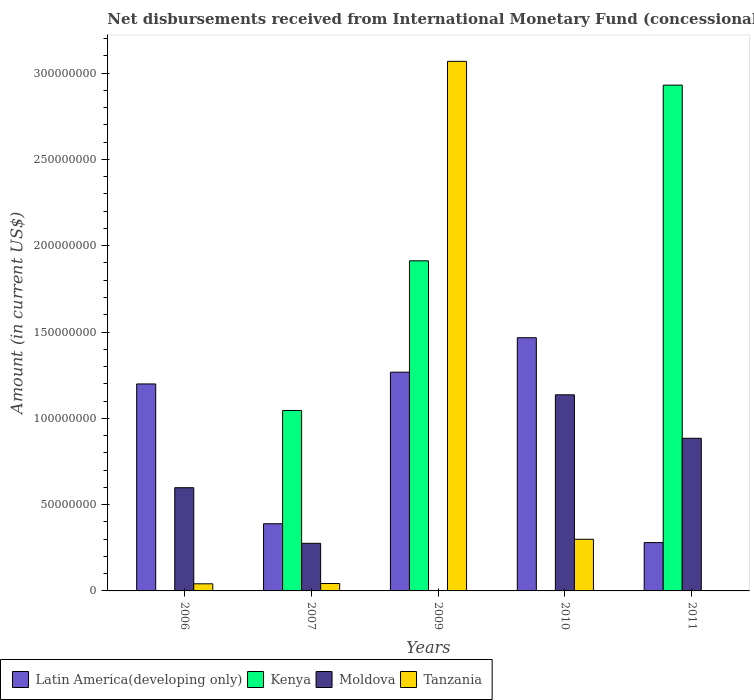How many different coloured bars are there?
Offer a terse response. 4. How many groups of bars are there?
Provide a short and direct response. 5. Are the number of bars per tick equal to the number of legend labels?
Your answer should be very brief. No. How many bars are there on the 2nd tick from the right?
Offer a very short reply. 3. What is the label of the 4th group of bars from the left?
Give a very brief answer. 2010. What is the amount of disbursements received from International Monetary Fund in Latin America(developing only) in 2010?
Ensure brevity in your answer.  1.47e+08. Across all years, what is the maximum amount of disbursements received from International Monetary Fund in Moldova?
Your answer should be very brief. 1.14e+08. In which year was the amount of disbursements received from International Monetary Fund in Moldova maximum?
Make the answer very short. 2010. What is the total amount of disbursements received from International Monetary Fund in Tanzania in the graph?
Provide a succinct answer. 3.45e+08. What is the difference between the amount of disbursements received from International Monetary Fund in Latin America(developing only) in 2006 and that in 2010?
Your answer should be compact. -2.68e+07. What is the difference between the amount of disbursements received from International Monetary Fund in Moldova in 2007 and the amount of disbursements received from International Monetary Fund in Tanzania in 2011?
Your answer should be compact. 2.76e+07. What is the average amount of disbursements received from International Monetary Fund in Latin America(developing only) per year?
Your answer should be very brief. 9.20e+07. In the year 2007, what is the difference between the amount of disbursements received from International Monetary Fund in Tanzania and amount of disbursements received from International Monetary Fund in Moldova?
Offer a very short reply. -2.33e+07. What is the ratio of the amount of disbursements received from International Monetary Fund in Latin America(developing only) in 2006 to that in 2010?
Offer a very short reply. 0.82. Is the amount of disbursements received from International Monetary Fund in Latin America(developing only) in 2006 less than that in 2010?
Your response must be concise. Yes. What is the difference between the highest and the second highest amount of disbursements received from International Monetary Fund in Tanzania?
Your answer should be compact. 2.77e+08. What is the difference between the highest and the lowest amount of disbursements received from International Monetary Fund in Kenya?
Make the answer very short. 2.93e+08. In how many years, is the amount of disbursements received from International Monetary Fund in Kenya greater than the average amount of disbursements received from International Monetary Fund in Kenya taken over all years?
Offer a terse response. 2. Is it the case that in every year, the sum of the amount of disbursements received from International Monetary Fund in Tanzania and amount of disbursements received from International Monetary Fund in Kenya is greater than the amount of disbursements received from International Monetary Fund in Latin America(developing only)?
Your response must be concise. No. How many bars are there?
Offer a terse response. 16. Are all the bars in the graph horizontal?
Provide a succinct answer. No. What is the difference between two consecutive major ticks on the Y-axis?
Your response must be concise. 5.00e+07. Are the values on the major ticks of Y-axis written in scientific E-notation?
Your answer should be compact. No. Does the graph contain any zero values?
Ensure brevity in your answer.  Yes. Does the graph contain grids?
Your answer should be very brief. No. How many legend labels are there?
Offer a terse response. 4. What is the title of the graph?
Ensure brevity in your answer.  Net disbursements received from International Monetary Fund (concessional). Does "Uganda" appear as one of the legend labels in the graph?
Your answer should be very brief. No. What is the label or title of the X-axis?
Keep it short and to the point. Years. What is the label or title of the Y-axis?
Your response must be concise. Amount (in current US$). What is the Amount (in current US$) in Latin America(developing only) in 2006?
Your answer should be very brief. 1.20e+08. What is the Amount (in current US$) of Kenya in 2006?
Ensure brevity in your answer.  0. What is the Amount (in current US$) in Moldova in 2006?
Keep it short and to the point. 5.98e+07. What is the Amount (in current US$) of Tanzania in 2006?
Give a very brief answer. 4.12e+06. What is the Amount (in current US$) of Latin America(developing only) in 2007?
Your response must be concise. 3.89e+07. What is the Amount (in current US$) in Kenya in 2007?
Provide a short and direct response. 1.05e+08. What is the Amount (in current US$) of Moldova in 2007?
Give a very brief answer. 2.76e+07. What is the Amount (in current US$) of Tanzania in 2007?
Your answer should be very brief. 4.29e+06. What is the Amount (in current US$) in Latin America(developing only) in 2009?
Keep it short and to the point. 1.27e+08. What is the Amount (in current US$) in Kenya in 2009?
Ensure brevity in your answer.  1.91e+08. What is the Amount (in current US$) in Tanzania in 2009?
Your answer should be very brief. 3.07e+08. What is the Amount (in current US$) in Latin America(developing only) in 2010?
Provide a succinct answer. 1.47e+08. What is the Amount (in current US$) in Moldova in 2010?
Provide a succinct answer. 1.14e+08. What is the Amount (in current US$) of Tanzania in 2010?
Ensure brevity in your answer.  2.99e+07. What is the Amount (in current US$) of Latin America(developing only) in 2011?
Give a very brief answer. 2.80e+07. What is the Amount (in current US$) in Kenya in 2011?
Provide a short and direct response. 2.93e+08. What is the Amount (in current US$) in Moldova in 2011?
Provide a short and direct response. 8.84e+07. What is the Amount (in current US$) of Tanzania in 2011?
Ensure brevity in your answer.  0. Across all years, what is the maximum Amount (in current US$) in Latin America(developing only)?
Your answer should be compact. 1.47e+08. Across all years, what is the maximum Amount (in current US$) in Kenya?
Provide a succinct answer. 2.93e+08. Across all years, what is the maximum Amount (in current US$) of Moldova?
Provide a short and direct response. 1.14e+08. Across all years, what is the maximum Amount (in current US$) of Tanzania?
Offer a very short reply. 3.07e+08. Across all years, what is the minimum Amount (in current US$) of Latin America(developing only)?
Your answer should be compact. 2.80e+07. Across all years, what is the minimum Amount (in current US$) in Kenya?
Your answer should be very brief. 0. Across all years, what is the minimum Amount (in current US$) in Tanzania?
Your response must be concise. 0. What is the total Amount (in current US$) of Latin America(developing only) in the graph?
Your response must be concise. 4.60e+08. What is the total Amount (in current US$) in Kenya in the graph?
Offer a very short reply. 5.89e+08. What is the total Amount (in current US$) in Moldova in the graph?
Your answer should be very brief. 2.89e+08. What is the total Amount (in current US$) in Tanzania in the graph?
Keep it short and to the point. 3.45e+08. What is the difference between the Amount (in current US$) in Latin America(developing only) in 2006 and that in 2007?
Your answer should be compact. 8.10e+07. What is the difference between the Amount (in current US$) in Moldova in 2006 and that in 2007?
Your response must be concise. 3.22e+07. What is the difference between the Amount (in current US$) in Tanzania in 2006 and that in 2007?
Your answer should be very brief. -1.66e+05. What is the difference between the Amount (in current US$) of Latin America(developing only) in 2006 and that in 2009?
Your response must be concise. -6.82e+06. What is the difference between the Amount (in current US$) of Tanzania in 2006 and that in 2009?
Ensure brevity in your answer.  -3.03e+08. What is the difference between the Amount (in current US$) of Latin America(developing only) in 2006 and that in 2010?
Your answer should be compact. -2.68e+07. What is the difference between the Amount (in current US$) in Moldova in 2006 and that in 2010?
Ensure brevity in your answer.  -5.38e+07. What is the difference between the Amount (in current US$) in Tanzania in 2006 and that in 2010?
Offer a very short reply. -2.58e+07. What is the difference between the Amount (in current US$) in Latin America(developing only) in 2006 and that in 2011?
Make the answer very short. 9.19e+07. What is the difference between the Amount (in current US$) in Moldova in 2006 and that in 2011?
Your answer should be compact. -2.86e+07. What is the difference between the Amount (in current US$) in Latin America(developing only) in 2007 and that in 2009?
Your answer should be compact. -8.78e+07. What is the difference between the Amount (in current US$) in Kenya in 2007 and that in 2009?
Your response must be concise. -8.67e+07. What is the difference between the Amount (in current US$) of Tanzania in 2007 and that in 2009?
Keep it short and to the point. -3.03e+08. What is the difference between the Amount (in current US$) in Latin America(developing only) in 2007 and that in 2010?
Your response must be concise. -1.08e+08. What is the difference between the Amount (in current US$) of Moldova in 2007 and that in 2010?
Your answer should be compact. -8.60e+07. What is the difference between the Amount (in current US$) in Tanzania in 2007 and that in 2010?
Your response must be concise. -2.56e+07. What is the difference between the Amount (in current US$) of Latin America(developing only) in 2007 and that in 2011?
Ensure brevity in your answer.  1.09e+07. What is the difference between the Amount (in current US$) of Kenya in 2007 and that in 2011?
Keep it short and to the point. -1.88e+08. What is the difference between the Amount (in current US$) in Moldova in 2007 and that in 2011?
Make the answer very short. -6.09e+07. What is the difference between the Amount (in current US$) of Latin America(developing only) in 2009 and that in 2010?
Offer a terse response. -2.00e+07. What is the difference between the Amount (in current US$) of Tanzania in 2009 and that in 2010?
Make the answer very short. 2.77e+08. What is the difference between the Amount (in current US$) in Latin America(developing only) in 2009 and that in 2011?
Give a very brief answer. 9.87e+07. What is the difference between the Amount (in current US$) of Kenya in 2009 and that in 2011?
Your answer should be very brief. -1.02e+08. What is the difference between the Amount (in current US$) of Latin America(developing only) in 2010 and that in 2011?
Keep it short and to the point. 1.19e+08. What is the difference between the Amount (in current US$) of Moldova in 2010 and that in 2011?
Provide a succinct answer. 2.52e+07. What is the difference between the Amount (in current US$) of Latin America(developing only) in 2006 and the Amount (in current US$) of Kenya in 2007?
Your answer should be very brief. 1.54e+07. What is the difference between the Amount (in current US$) in Latin America(developing only) in 2006 and the Amount (in current US$) in Moldova in 2007?
Ensure brevity in your answer.  9.23e+07. What is the difference between the Amount (in current US$) of Latin America(developing only) in 2006 and the Amount (in current US$) of Tanzania in 2007?
Provide a succinct answer. 1.16e+08. What is the difference between the Amount (in current US$) in Moldova in 2006 and the Amount (in current US$) in Tanzania in 2007?
Offer a very short reply. 5.55e+07. What is the difference between the Amount (in current US$) in Latin America(developing only) in 2006 and the Amount (in current US$) in Kenya in 2009?
Offer a very short reply. -7.13e+07. What is the difference between the Amount (in current US$) in Latin America(developing only) in 2006 and the Amount (in current US$) in Tanzania in 2009?
Your response must be concise. -1.87e+08. What is the difference between the Amount (in current US$) in Moldova in 2006 and the Amount (in current US$) in Tanzania in 2009?
Your answer should be very brief. -2.47e+08. What is the difference between the Amount (in current US$) of Latin America(developing only) in 2006 and the Amount (in current US$) of Moldova in 2010?
Give a very brief answer. 6.30e+06. What is the difference between the Amount (in current US$) in Latin America(developing only) in 2006 and the Amount (in current US$) in Tanzania in 2010?
Make the answer very short. 9.00e+07. What is the difference between the Amount (in current US$) of Moldova in 2006 and the Amount (in current US$) of Tanzania in 2010?
Your answer should be very brief. 2.99e+07. What is the difference between the Amount (in current US$) in Latin America(developing only) in 2006 and the Amount (in current US$) in Kenya in 2011?
Your response must be concise. -1.73e+08. What is the difference between the Amount (in current US$) of Latin America(developing only) in 2006 and the Amount (in current US$) of Moldova in 2011?
Your answer should be compact. 3.15e+07. What is the difference between the Amount (in current US$) of Latin America(developing only) in 2007 and the Amount (in current US$) of Kenya in 2009?
Give a very brief answer. -1.52e+08. What is the difference between the Amount (in current US$) of Latin America(developing only) in 2007 and the Amount (in current US$) of Tanzania in 2009?
Make the answer very short. -2.68e+08. What is the difference between the Amount (in current US$) in Kenya in 2007 and the Amount (in current US$) in Tanzania in 2009?
Offer a very short reply. -2.02e+08. What is the difference between the Amount (in current US$) in Moldova in 2007 and the Amount (in current US$) in Tanzania in 2009?
Keep it short and to the point. -2.79e+08. What is the difference between the Amount (in current US$) in Latin America(developing only) in 2007 and the Amount (in current US$) in Moldova in 2010?
Give a very brief answer. -7.47e+07. What is the difference between the Amount (in current US$) of Latin America(developing only) in 2007 and the Amount (in current US$) of Tanzania in 2010?
Make the answer very short. 8.99e+06. What is the difference between the Amount (in current US$) of Kenya in 2007 and the Amount (in current US$) of Moldova in 2010?
Offer a terse response. -9.09e+06. What is the difference between the Amount (in current US$) of Kenya in 2007 and the Amount (in current US$) of Tanzania in 2010?
Your answer should be very brief. 7.46e+07. What is the difference between the Amount (in current US$) in Moldova in 2007 and the Amount (in current US$) in Tanzania in 2010?
Your answer should be very brief. -2.35e+06. What is the difference between the Amount (in current US$) of Latin America(developing only) in 2007 and the Amount (in current US$) of Kenya in 2011?
Your response must be concise. -2.54e+08. What is the difference between the Amount (in current US$) in Latin America(developing only) in 2007 and the Amount (in current US$) in Moldova in 2011?
Your answer should be compact. -4.95e+07. What is the difference between the Amount (in current US$) of Kenya in 2007 and the Amount (in current US$) of Moldova in 2011?
Ensure brevity in your answer.  1.61e+07. What is the difference between the Amount (in current US$) of Latin America(developing only) in 2009 and the Amount (in current US$) of Moldova in 2010?
Your response must be concise. 1.31e+07. What is the difference between the Amount (in current US$) in Latin America(developing only) in 2009 and the Amount (in current US$) in Tanzania in 2010?
Provide a succinct answer. 9.68e+07. What is the difference between the Amount (in current US$) in Kenya in 2009 and the Amount (in current US$) in Moldova in 2010?
Provide a succinct answer. 7.76e+07. What is the difference between the Amount (in current US$) of Kenya in 2009 and the Amount (in current US$) of Tanzania in 2010?
Give a very brief answer. 1.61e+08. What is the difference between the Amount (in current US$) of Latin America(developing only) in 2009 and the Amount (in current US$) of Kenya in 2011?
Provide a succinct answer. -1.66e+08. What is the difference between the Amount (in current US$) in Latin America(developing only) in 2009 and the Amount (in current US$) in Moldova in 2011?
Provide a short and direct response. 3.83e+07. What is the difference between the Amount (in current US$) of Kenya in 2009 and the Amount (in current US$) of Moldova in 2011?
Ensure brevity in your answer.  1.03e+08. What is the difference between the Amount (in current US$) of Latin America(developing only) in 2010 and the Amount (in current US$) of Kenya in 2011?
Provide a succinct answer. -1.46e+08. What is the difference between the Amount (in current US$) in Latin America(developing only) in 2010 and the Amount (in current US$) in Moldova in 2011?
Your answer should be very brief. 5.83e+07. What is the average Amount (in current US$) in Latin America(developing only) per year?
Your response must be concise. 9.20e+07. What is the average Amount (in current US$) in Kenya per year?
Your answer should be compact. 1.18e+08. What is the average Amount (in current US$) in Moldova per year?
Ensure brevity in your answer.  5.79e+07. What is the average Amount (in current US$) of Tanzania per year?
Keep it short and to the point. 6.90e+07. In the year 2006, what is the difference between the Amount (in current US$) of Latin America(developing only) and Amount (in current US$) of Moldova?
Offer a terse response. 6.01e+07. In the year 2006, what is the difference between the Amount (in current US$) of Latin America(developing only) and Amount (in current US$) of Tanzania?
Give a very brief answer. 1.16e+08. In the year 2006, what is the difference between the Amount (in current US$) of Moldova and Amount (in current US$) of Tanzania?
Provide a succinct answer. 5.57e+07. In the year 2007, what is the difference between the Amount (in current US$) of Latin America(developing only) and Amount (in current US$) of Kenya?
Your answer should be compact. -6.56e+07. In the year 2007, what is the difference between the Amount (in current US$) of Latin America(developing only) and Amount (in current US$) of Moldova?
Give a very brief answer. 1.13e+07. In the year 2007, what is the difference between the Amount (in current US$) of Latin America(developing only) and Amount (in current US$) of Tanzania?
Your answer should be very brief. 3.46e+07. In the year 2007, what is the difference between the Amount (in current US$) in Kenya and Amount (in current US$) in Moldova?
Give a very brief answer. 7.70e+07. In the year 2007, what is the difference between the Amount (in current US$) of Kenya and Amount (in current US$) of Tanzania?
Provide a short and direct response. 1.00e+08. In the year 2007, what is the difference between the Amount (in current US$) of Moldova and Amount (in current US$) of Tanzania?
Your answer should be compact. 2.33e+07. In the year 2009, what is the difference between the Amount (in current US$) of Latin America(developing only) and Amount (in current US$) of Kenya?
Your answer should be compact. -6.45e+07. In the year 2009, what is the difference between the Amount (in current US$) of Latin America(developing only) and Amount (in current US$) of Tanzania?
Offer a terse response. -1.80e+08. In the year 2009, what is the difference between the Amount (in current US$) of Kenya and Amount (in current US$) of Tanzania?
Your response must be concise. -1.16e+08. In the year 2010, what is the difference between the Amount (in current US$) in Latin America(developing only) and Amount (in current US$) in Moldova?
Provide a succinct answer. 3.31e+07. In the year 2010, what is the difference between the Amount (in current US$) of Latin America(developing only) and Amount (in current US$) of Tanzania?
Give a very brief answer. 1.17e+08. In the year 2010, what is the difference between the Amount (in current US$) of Moldova and Amount (in current US$) of Tanzania?
Offer a terse response. 8.37e+07. In the year 2011, what is the difference between the Amount (in current US$) in Latin America(developing only) and Amount (in current US$) in Kenya?
Offer a terse response. -2.65e+08. In the year 2011, what is the difference between the Amount (in current US$) of Latin America(developing only) and Amount (in current US$) of Moldova?
Give a very brief answer. -6.04e+07. In the year 2011, what is the difference between the Amount (in current US$) of Kenya and Amount (in current US$) of Moldova?
Offer a terse response. 2.05e+08. What is the ratio of the Amount (in current US$) of Latin America(developing only) in 2006 to that in 2007?
Your answer should be very brief. 3.08. What is the ratio of the Amount (in current US$) in Moldova in 2006 to that in 2007?
Your answer should be very brief. 2.17. What is the ratio of the Amount (in current US$) in Tanzania in 2006 to that in 2007?
Give a very brief answer. 0.96. What is the ratio of the Amount (in current US$) of Latin America(developing only) in 2006 to that in 2009?
Offer a very short reply. 0.95. What is the ratio of the Amount (in current US$) of Tanzania in 2006 to that in 2009?
Provide a short and direct response. 0.01. What is the ratio of the Amount (in current US$) of Latin America(developing only) in 2006 to that in 2010?
Your answer should be very brief. 0.82. What is the ratio of the Amount (in current US$) in Moldova in 2006 to that in 2010?
Give a very brief answer. 0.53. What is the ratio of the Amount (in current US$) of Tanzania in 2006 to that in 2010?
Your answer should be very brief. 0.14. What is the ratio of the Amount (in current US$) of Latin America(developing only) in 2006 to that in 2011?
Give a very brief answer. 4.28. What is the ratio of the Amount (in current US$) of Moldova in 2006 to that in 2011?
Make the answer very short. 0.68. What is the ratio of the Amount (in current US$) of Latin America(developing only) in 2007 to that in 2009?
Give a very brief answer. 0.31. What is the ratio of the Amount (in current US$) of Kenya in 2007 to that in 2009?
Your answer should be compact. 0.55. What is the ratio of the Amount (in current US$) in Tanzania in 2007 to that in 2009?
Make the answer very short. 0.01. What is the ratio of the Amount (in current US$) of Latin America(developing only) in 2007 to that in 2010?
Offer a terse response. 0.27. What is the ratio of the Amount (in current US$) in Moldova in 2007 to that in 2010?
Provide a short and direct response. 0.24. What is the ratio of the Amount (in current US$) of Tanzania in 2007 to that in 2010?
Your answer should be very brief. 0.14. What is the ratio of the Amount (in current US$) in Latin America(developing only) in 2007 to that in 2011?
Keep it short and to the point. 1.39. What is the ratio of the Amount (in current US$) in Kenya in 2007 to that in 2011?
Keep it short and to the point. 0.36. What is the ratio of the Amount (in current US$) of Moldova in 2007 to that in 2011?
Offer a very short reply. 0.31. What is the ratio of the Amount (in current US$) in Latin America(developing only) in 2009 to that in 2010?
Provide a short and direct response. 0.86. What is the ratio of the Amount (in current US$) of Tanzania in 2009 to that in 2010?
Provide a short and direct response. 10.25. What is the ratio of the Amount (in current US$) of Latin America(developing only) in 2009 to that in 2011?
Make the answer very short. 4.53. What is the ratio of the Amount (in current US$) of Kenya in 2009 to that in 2011?
Your response must be concise. 0.65. What is the ratio of the Amount (in current US$) in Latin America(developing only) in 2010 to that in 2011?
Give a very brief answer. 5.24. What is the ratio of the Amount (in current US$) in Moldova in 2010 to that in 2011?
Provide a short and direct response. 1.28. What is the difference between the highest and the second highest Amount (in current US$) of Latin America(developing only)?
Provide a succinct answer. 2.00e+07. What is the difference between the highest and the second highest Amount (in current US$) of Kenya?
Offer a terse response. 1.02e+08. What is the difference between the highest and the second highest Amount (in current US$) in Moldova?
Ensure brevity in your answer.  2.52e+07. What is the difference between the highest and the second highest Amount (in current US$) in Tanzania?
Provide a succinct answer. 2.77e+08. What is the difference between the highest and the lowest Amount (in current US$) in Latin America(developing only)?
Your response must be concise. 1.19e+08. What is the difference between the highest and the lowest Amount (in current US$) in Kenya?
Make the answer very short. 2.93e+08. What is the difference between the highest and the lowest Amount (in current US$) of Moldova?
Your answer should be compact. 1.14e+08. What is the difference between the highest and the lowest Amount (in current US$) in Tanzania?
Your answer should be very brief. 3.07e+08. 